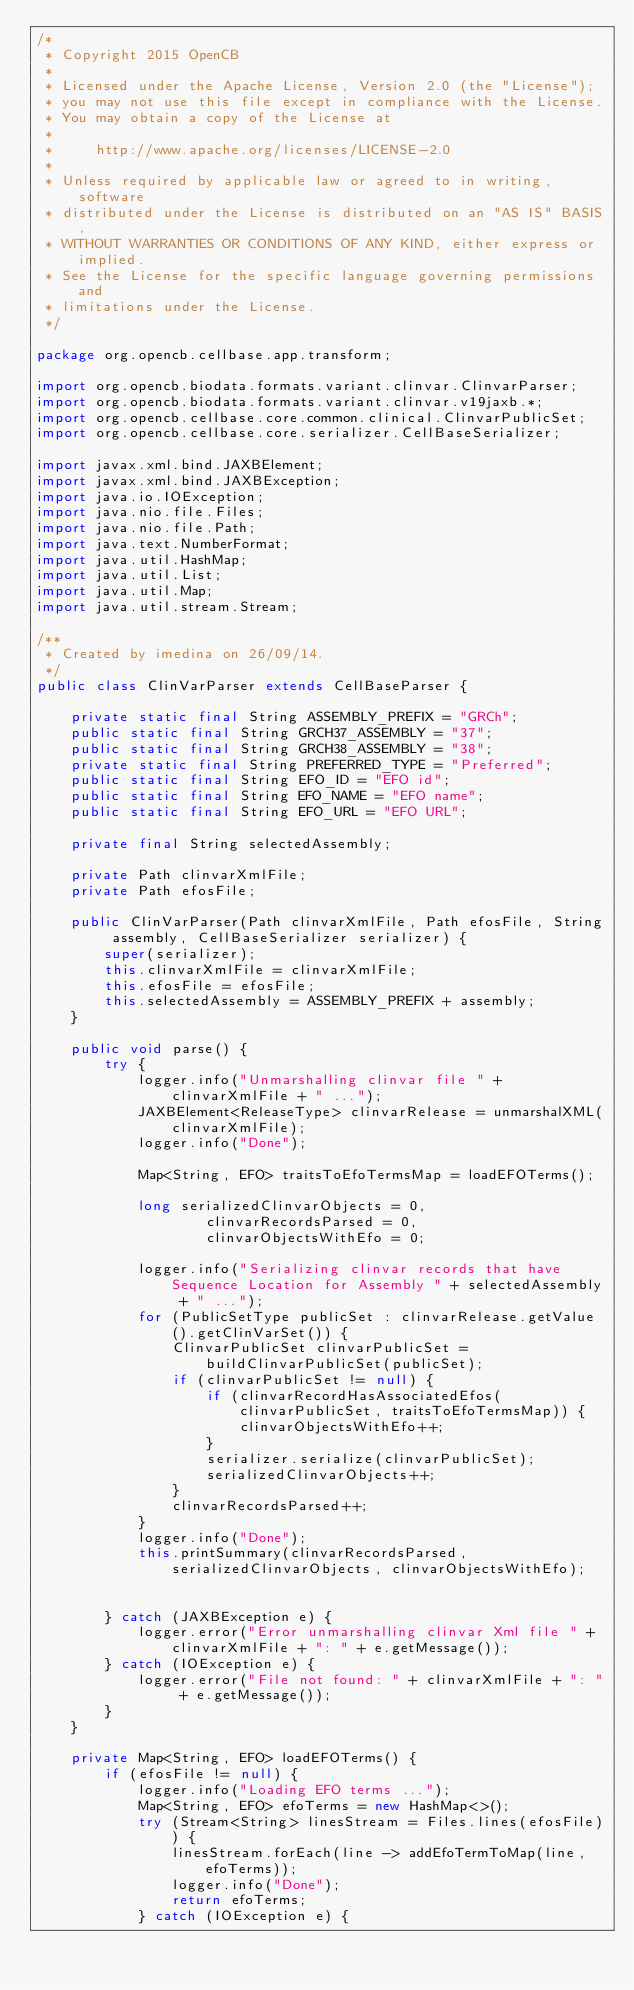Convert code to text. <code><loc_0><loc_0><loc_500><loc_500><_Java_>/*
 * Copyright 2015 OpenCB
 *
 * Licensed under the Apache License, Version 2.0 (the "License");
 * you may not use this file except in compliance with the License.
 * You may obtain a copy of the License at
 *
 *     http://www.apache.org/licenses/LICENSE-2.0
 *
 * Unless required by applicable law or agreed to in writing, software
 * distributed under the License is distributed on an "AS IS" BASIS,
 * WITHOUT WARRANTIES OR CONDITIONS OF ANY KIND, either express or implied.
 * See the License for the specific language governing permissions and
 * limitations under the License.
 */

package org.opencb.cellbase.app.transform;

import org.opencb.biodata.formats.variant.clinvar.ClinvarParser;
import org.opencb.biodata.formats.variant.clinvar.v19jaxb.*;
import org.opencb.cellbase.core.common.clinical.ClinvarPublicSet;
import org.opencb.cellbase.core.serializer.CellBaseSerializer;

import javax.xml.bind.JAXBElement;
import javax.xml.bind.JAXBException;
import java.io.IOException;
import java.nio.file.Files;
import java.nio.file.Path;
import java.text.NumberFormat;
import java.util.HashMap;
import java.util.List;
import java.util.Map;
import java.util.stream.Stream;

/**
 * Created by imedina on 26/09/14.
 */
public class ClinVarParser extends CellBaseParser {

    private static final String ASSEMBLY_PREFIX = "GRCh";
    public static final String GRCH37_ASSEMBLY = "37";
    public static final String GRCH38_ASSEMBLY = "38";
    private static final String PREFERRED_TYPE = "Preferred";
    public static final String EFO_ID = "EFO id";
    public static final String EFO_NAME = "EFO name";
    public static final String EFO_URL = "EFO URL";

    private final String selectedAssembly;

    private Path clinvarXmlFile;
    private Path efosFile;

    public ClinVarParser(Path clinvarXmlFile, Path efosFile, String assembly, CellBaseSerializer serializer) {
        super(serializer);
        this.clinvarXmlFile = clinvarXmlFile;
        this.efosFile = efosFile;
        this.selectedAssembly = ASSEMBLY_PREFIX + assembly;
    }

    public void parse() {
        try {
            logger.info("Unmarshalling clinvar file " + clinvarXmlFile + " ...");
            JAXBElement<ReleaseType> clinvarRelease = unmarshalXML(clinvarXmlFile);
            logger.info("Done");

            Map<String, EFO> traitsToEfoTermsMap = loadEFOTerms();

            long serializedClinvarObjects = 0,
                    clinvarRecordsParsed = 0,
                    clinvarObjectsWithEfo = 0;

            logger.info("Serializing clinvar records that have Sequence Location for Assembly " + selectedAssembly + " ...");
            for (PublicSetType publicSet : clinvarRelease.getValue().getClinVarSet()) {
                ClinvarPublicSet clinvarPublicSet = buildClinvarPublicSet(publicSet);
                if (clinvarPublicSet != null) {
                    if (clinvarRecordHasAssociatedEfos(clinvarPublicSet, traitsToEfoTermsMap)) {
                        clinvarObjectsWithEfo++;
                    }
                    serializer.serialize(clinvarPublicSet);
                    serializedClinvarObjects++;
                }
                clinvarRecordsParsed++;
            }
            logger.info("Done");
            this.printSummary(clinvarRecordsParsed, serializedClinvarObjects, clinvarObjectsWithEfo);


        } catch (JAXBException e) {
            logger.error("Error unmarshalling clinvar Xml file " + clinvarXmlFile + ": " + e.getMessage());
        } catch (IOException e) {
            logger.error("File not found: " + clinvarXmlFile + ": " + e.getMessage());
        }
    }

    private Map<String, EFO> loadEFOTerms() {
        if (efosFile != null) {
            logger.info("Loading EFO terms ...");
            Map<String, EFO> efoTerms = new HashMap<>();
            try (Stream<String> linesStream = Files.lines(efosFile)) {
                linesStream.forEach(line -> addEfoTermToMap(line, efoTerms));
                logger.info("Done");
                return efoTerms;
            } catch (IOException e) {</code> 